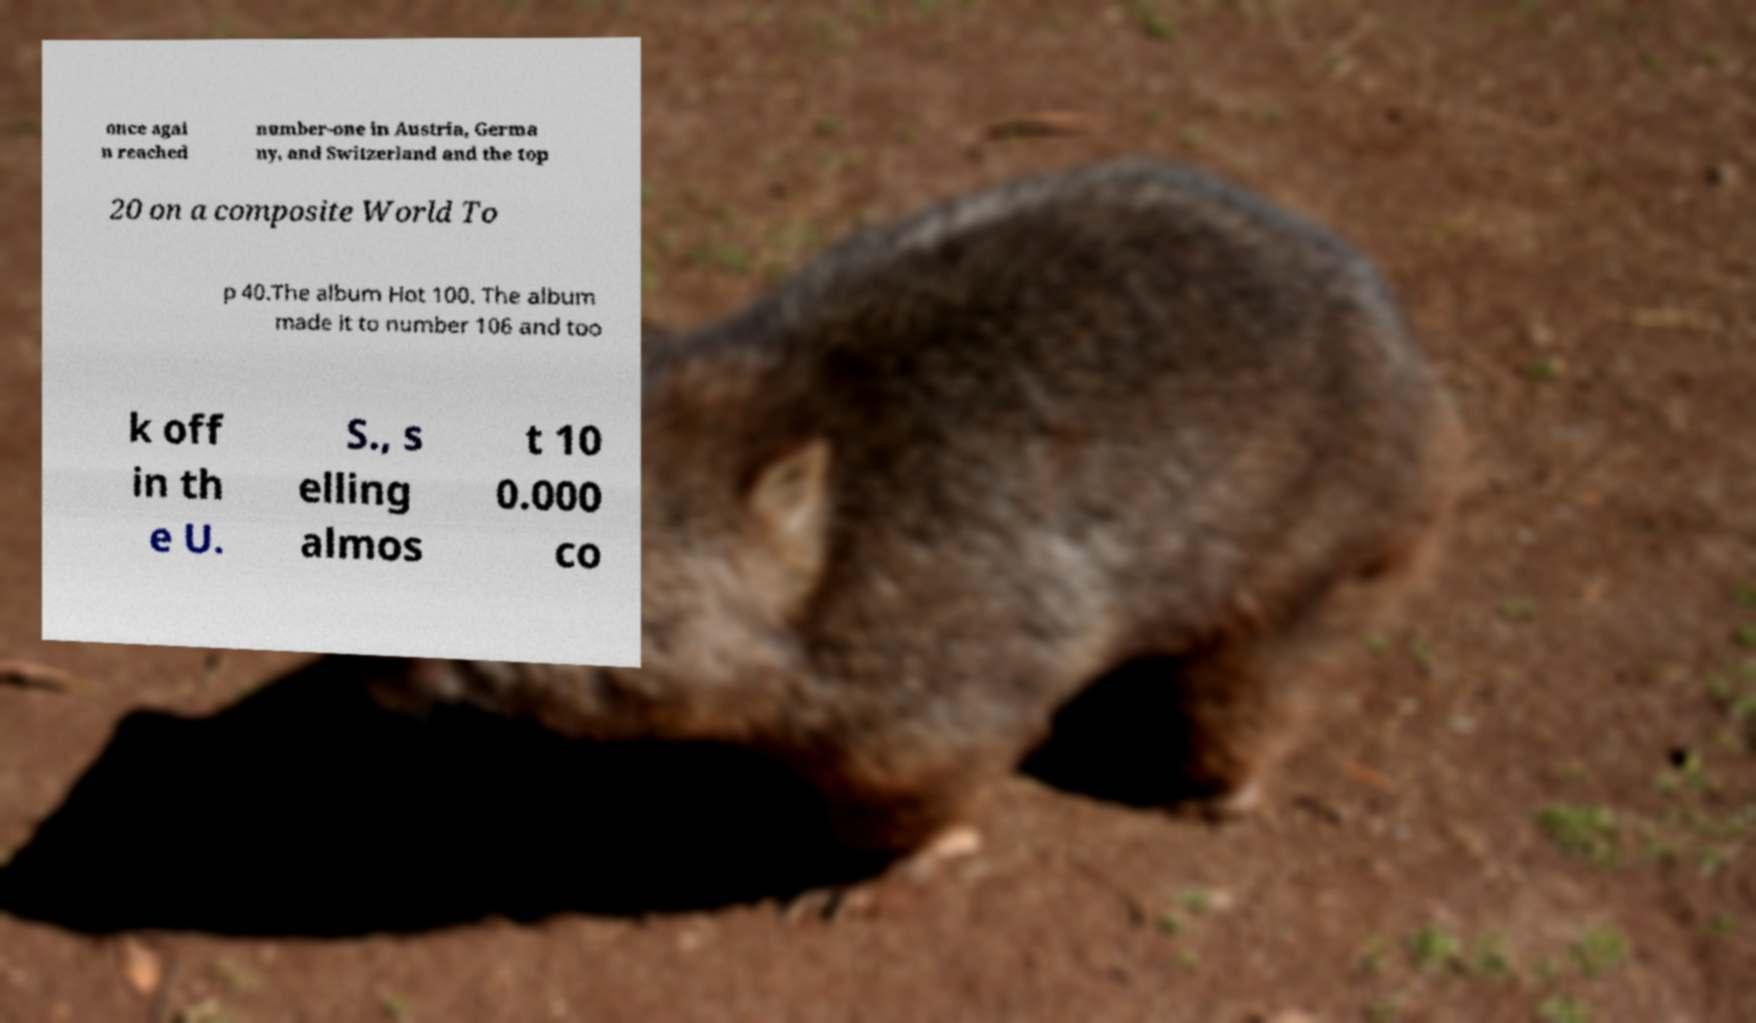Can you read and provide the text displayed in the image?This photo seems to have some interesting text. Can you extract and type it out for me? once agai n reached number-one in Austria, Germa ny, and Switzerland and the top 20 on a composite World To p 40.The album Hot 100. The album made it to number 106 and too k off in th e U. S., s elling almos t 10 0.000 co 